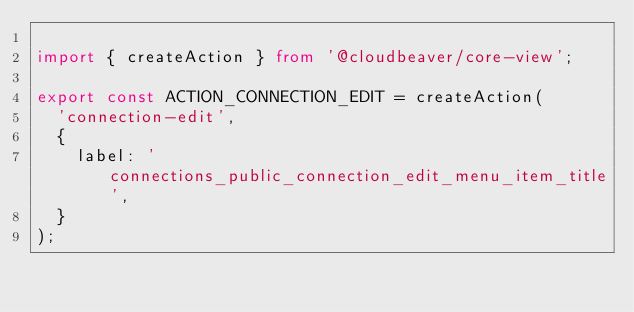<code> <loc_0><loc_0><loc_500><loc_500><_TypeScript_>
import { createAction } from '@cloudbeaver/core-view';

export const ACTION_CONNECTION_EDIT = createAction(
  'connection-edit',
  {
    label: 'connections_public_connection_edit_menu_item_title',
  }
);
</code> 